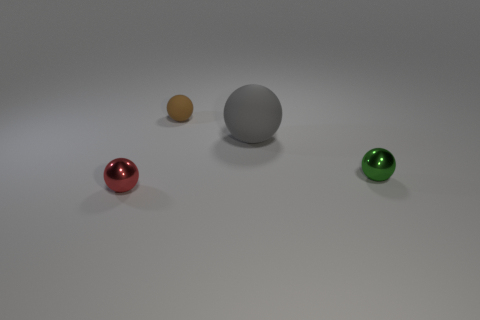Is the shape of the object that is left of the small brown rubber thing the same as  the gray object? yes 